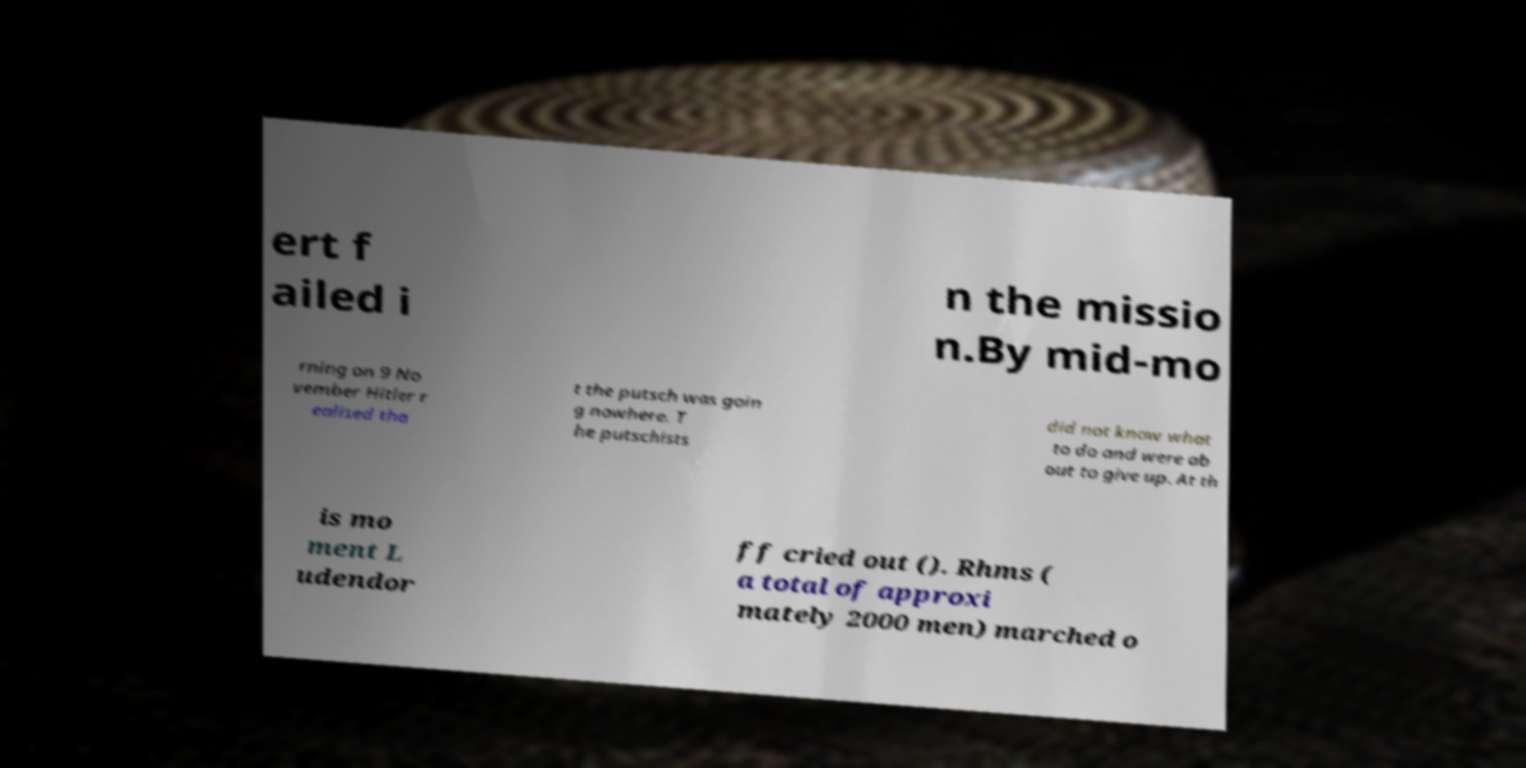Please identify and transcribe the text found in this image. ert f ailed i n the missio n.By mid-mo rning on 9 No vember Hitler r ealised tha t the putsch was goin g nowhere. T he putschists did not know what to do and were ab out to give up. At th is mo ment L udendor ff cried out (). Rhms ( a total of approxi mately 2000 men) marched o 